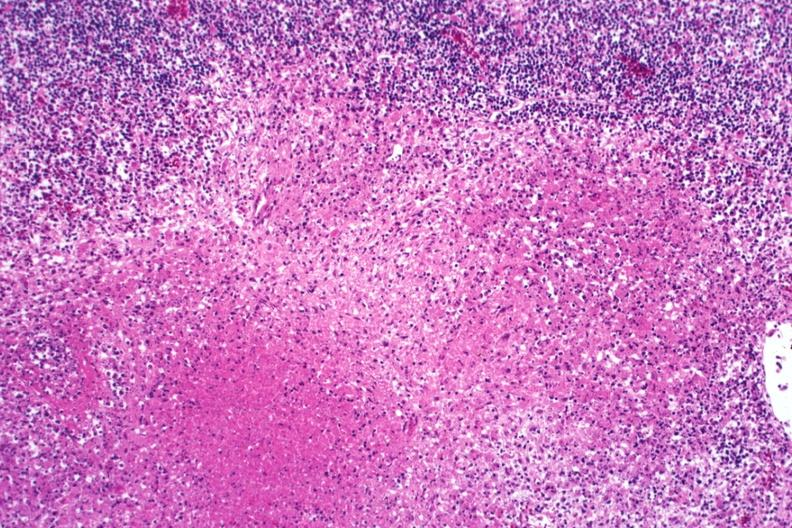what is present?
Answer the question using a single word or phrase. Tuberculosis 